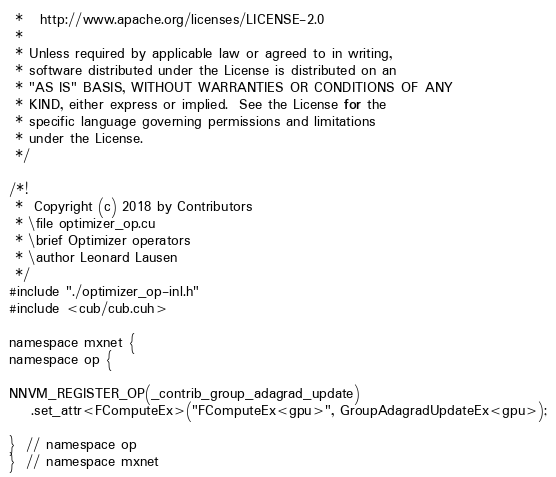Convert code to text. <code><loc_0><loc_0><loc_500><loc_500><_Cuda_> *   http://www.apache.org/licenses/LICENSE-2.0
 *
 * Unless required by applicable law or agreed to in writing,
 * software distributed under the License is distributed on an
 * "AS IS" BASIS, WITHOUT WARRANTIES OR CONDITIONS OF ANY
 * KIND, either express or implied.  See the License for the
 * specific language governing permissions and limitations
 * under the License.
 */

/*!
 *  Copyright (c) 2018 by Contributors
 * \file optimizer_op.cu
 * \brief Optimizer operators
 * \author Leonard Lausen
 */
#include "./optimizer_op-inl.h"
#include <cub/cub.cuh>

namespace mxnet {
namespace op {

NNVM_REGISTER_OP(_contrib_group_adagrad_update)
    .set_attr<FComputeEx>("FComputeEx<gpu>", GroupAdagradUpdateEx<gpu>);

}  // namespace op
}  // namespace mxnet
</code> 